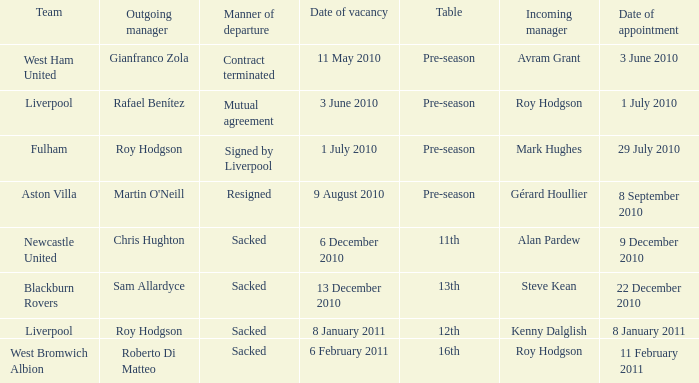How many incoming managers were there after Roy Hodgson left the position for the Fulham team? 1.0. 